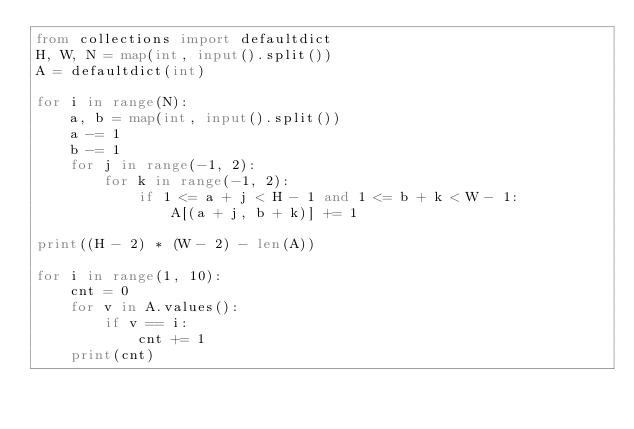Convert code to text. <code><loc_0><loc_0><loc_500><loc_500><_Python_>from collections import defaultdict
H, W, N = map(int, input().split())
A = defaultdict(int)

for i in range(N):
    a, b = map(int, input().split())
    a -= 1
    b -= 1
    for j in range(-1, 2):
        for k in range(-1, 2):
            if 1 <= a + j < H - 1 and 1 <= b + k < W - 1:
                A[(a + j, b + k)] += 1
                
print((H - 2) * (W - 2) - len(A))
                
for i in range(1, 10):
    cnt = 0
    for v in A.values():
        if v == i:
            cnt += 1
    print(cnt)</code> 